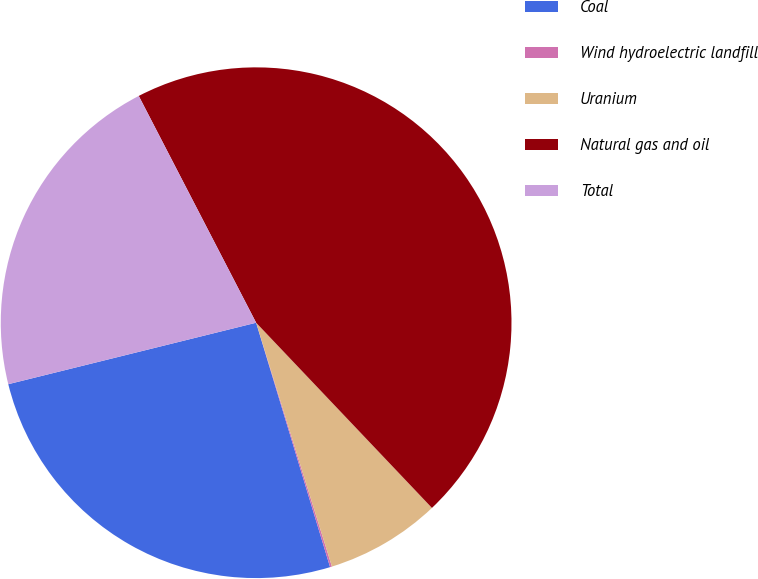Convert chart. <chart><loc_0><loc_0><loc_500><loc_500><pie_chart><fcel>Coal<fcel>Wind hydroelectric landfill<fcel>Uranium<fcel>Natural gas and oil<fcel>Total<nl><fcel>25.81%<fcel>0.12%<fcel>7.29%<fcel>45.52%<fcel>21.27%<nl></chart> 